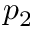Convert formula to latex. <formula><loc_0><loc_0><loc_500><loc_500>p _ { 2 }</formula> 